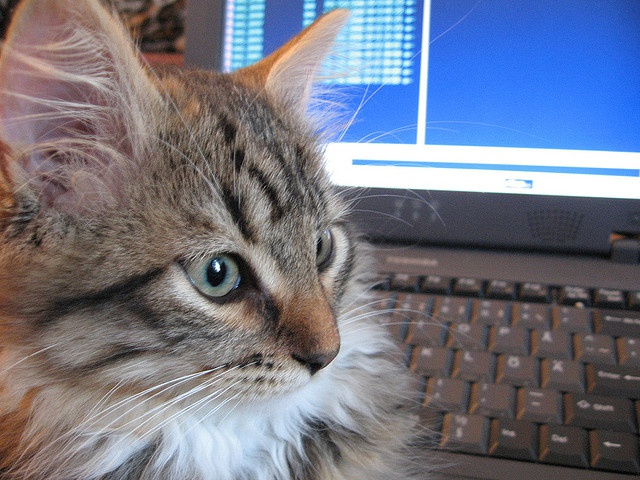Describe the objects in this image and their specific colors. I can see cat in black, gray, darkgray, and lightgray tones and laptop in black, gray, blue, and white tones in this image. 